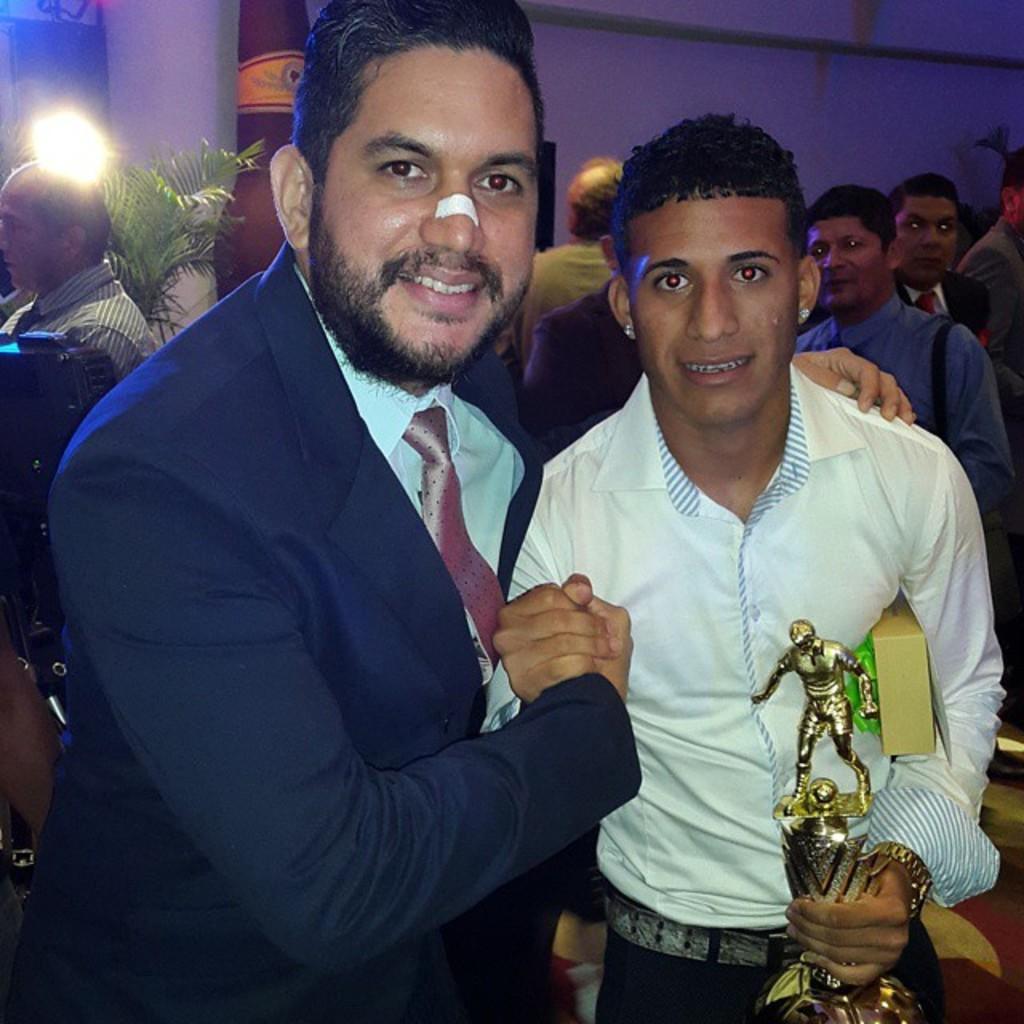In one or two sentences, can you explain what this image depicts? In this picture we can see a group of people standing where two men are smiling and a man holding a trophy with his hand and in the background we can see a tree, wall. 